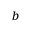Convert formula to latex. <formula><loc_0><loc_0><loc_500><loc_500>^ { b }</formula> 